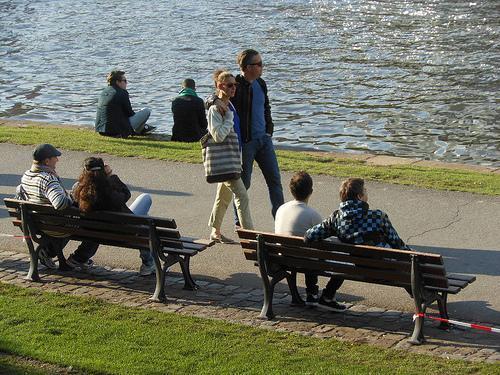How many benches are there?
Give a very brief answer. 2. 